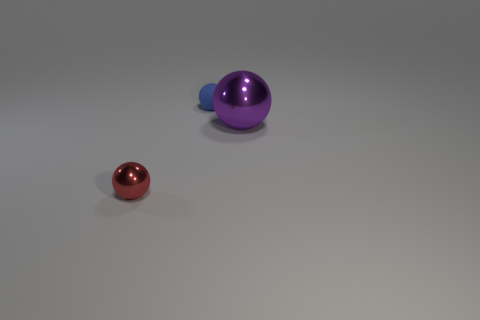Add 1 large things. How many objects exist? 4 Subtract 0 purple cylinders. How many objects are left? 3 Subtract all tiny metallic things. Subtract all blue matte spheres. How many objects are left? 1 Add 2 spheres. How many spheres are left? 5 Add 1 small cyan cubes. How many small cyan cubes exist? 1 